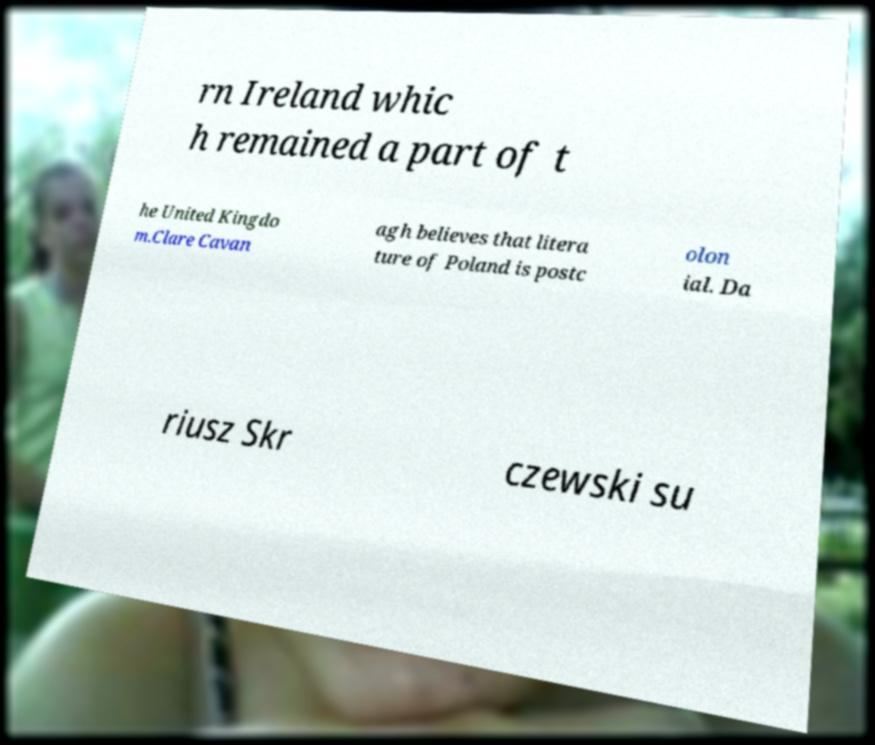For documentation purposes, I need the text within this image transcribed. Could you provide that? rn Ireland whic h remained a part of t he United Kingdo m.Clare Cavan agh believes that litera ture of Poland is postc olon ial. Da riusz Skr czewski su 